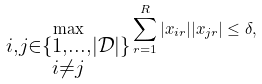<formula> <loc_0><loc_0><loc_500><loc_500>\max _ { \substack { i , j \in \{ 1 , \dots , | \mathcal { D } | \} \\ i \neq j } } \sum _ { r = 1 } ^ { R } | x _ { i r } | | x _ { j r } | \leq \delta ,</formula> 